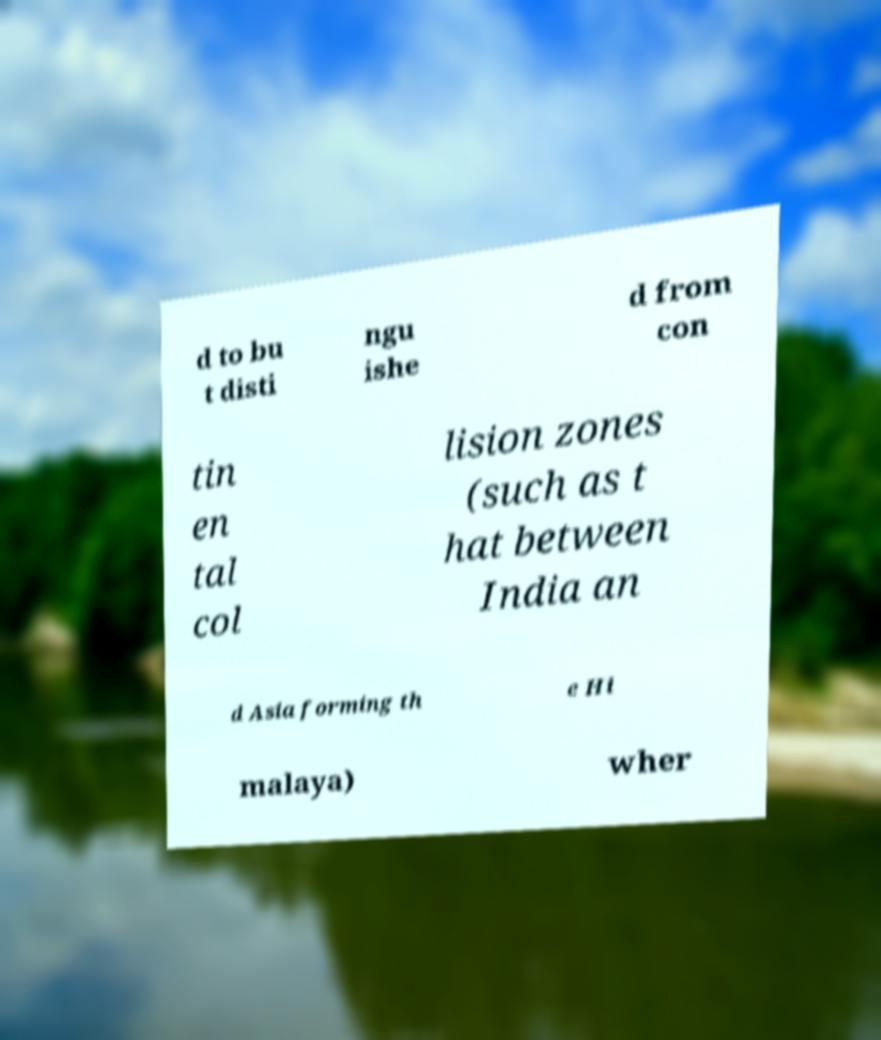Please identify and transcribe the text found in this image. d to bu t disti ngu ishe d from con tin en tal col lision zones (such as t hat between India an d Asia forming th e Hi malaya) wher 